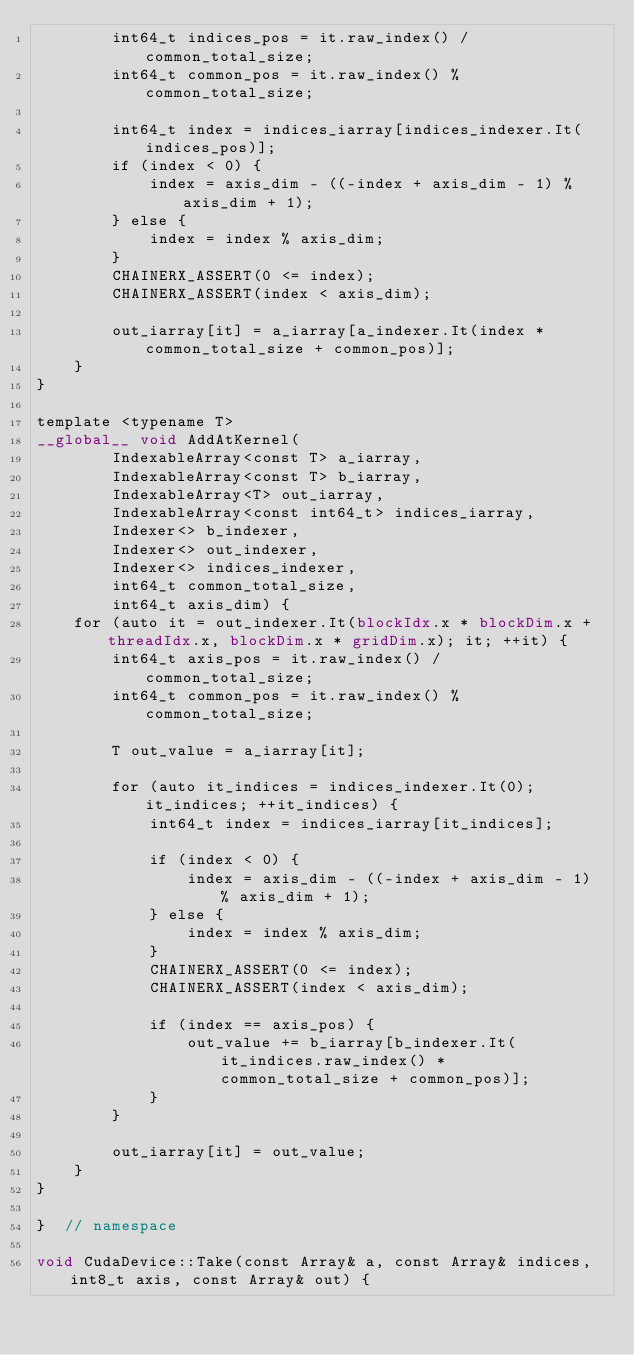<code> <loc_0><loc_0><loc_500><loc_500><_Cuda_>        int64_t indices_pos = it.raw_index() / common_total_size;
        int64_t common_pos = it.raw_index() % common_total_size;

        int64_t index = indices_iarray[indices_indexer.It(indices_pos)];
        if (index < 0) {
            index = axis_dim - ((-index + axis_dim - 1) % axis_dim + 1);
        } else {
            index = index % axis_dim;
        }
        CHAINERX_ASSERT(0 <= index);
        CHAINERX_ASSERT(index < axis_dim);

        out_iarray[it] = a_iarray[a_indexer.It(index * common_total_size + common_pos)];
    }
}

template <typename T>
__global__ void AddAtKernel(
        IndexableArray<const T> a_iarray,
        IndexableArray<const T> b_iarray,
        IndexableArray<T> out_iarray,
        IndexableArray<const int64_t> indices_iarray,
        Indexer<> b_indexer,
        Indexer<> out_indexer,
        Indexer<> indices_indexer,
        int64_t common_total_size,
        int64_t axis_dim) {
    for (auto it = out_indexer.It(blockIdx.x * blockDim.x + threadIdx.x, blockDim.x * gridDim.x); it; ++it) {
        int64_t axis_pos = it.raw_index() / common_total_size;
        int64_t common_pos = it.raw_index() % common_total_size;

        T out_value = a_iarray[it];

        for (auto it_indices = indices_indexer.It(0); it_indices; ++it_indices) {
            int64_t index = indices_iarray[it_indices];

            if (index < 0) {
                index = axis_dim - ((-index + axis_dim - 1) % axis_dim + 1);
            } else {
                index = index % axis_dim;
            }
            CHAINERX_ASSERT(0 <= index);
            CHAINERX_ASSERT(index < axis_dim);

            if (index == axis_pos) {
                out_value += b_iarray[b_indexer.It(it_indices.raw_index() * common_total_size + common_pos)];
            }
        }

        out_iarray[it] = out_value;
    }
}

}  // namespace

void CudaDevice::Take(const Array& a, const Array& indices, int8_t axis, const Array& out) {</code> 